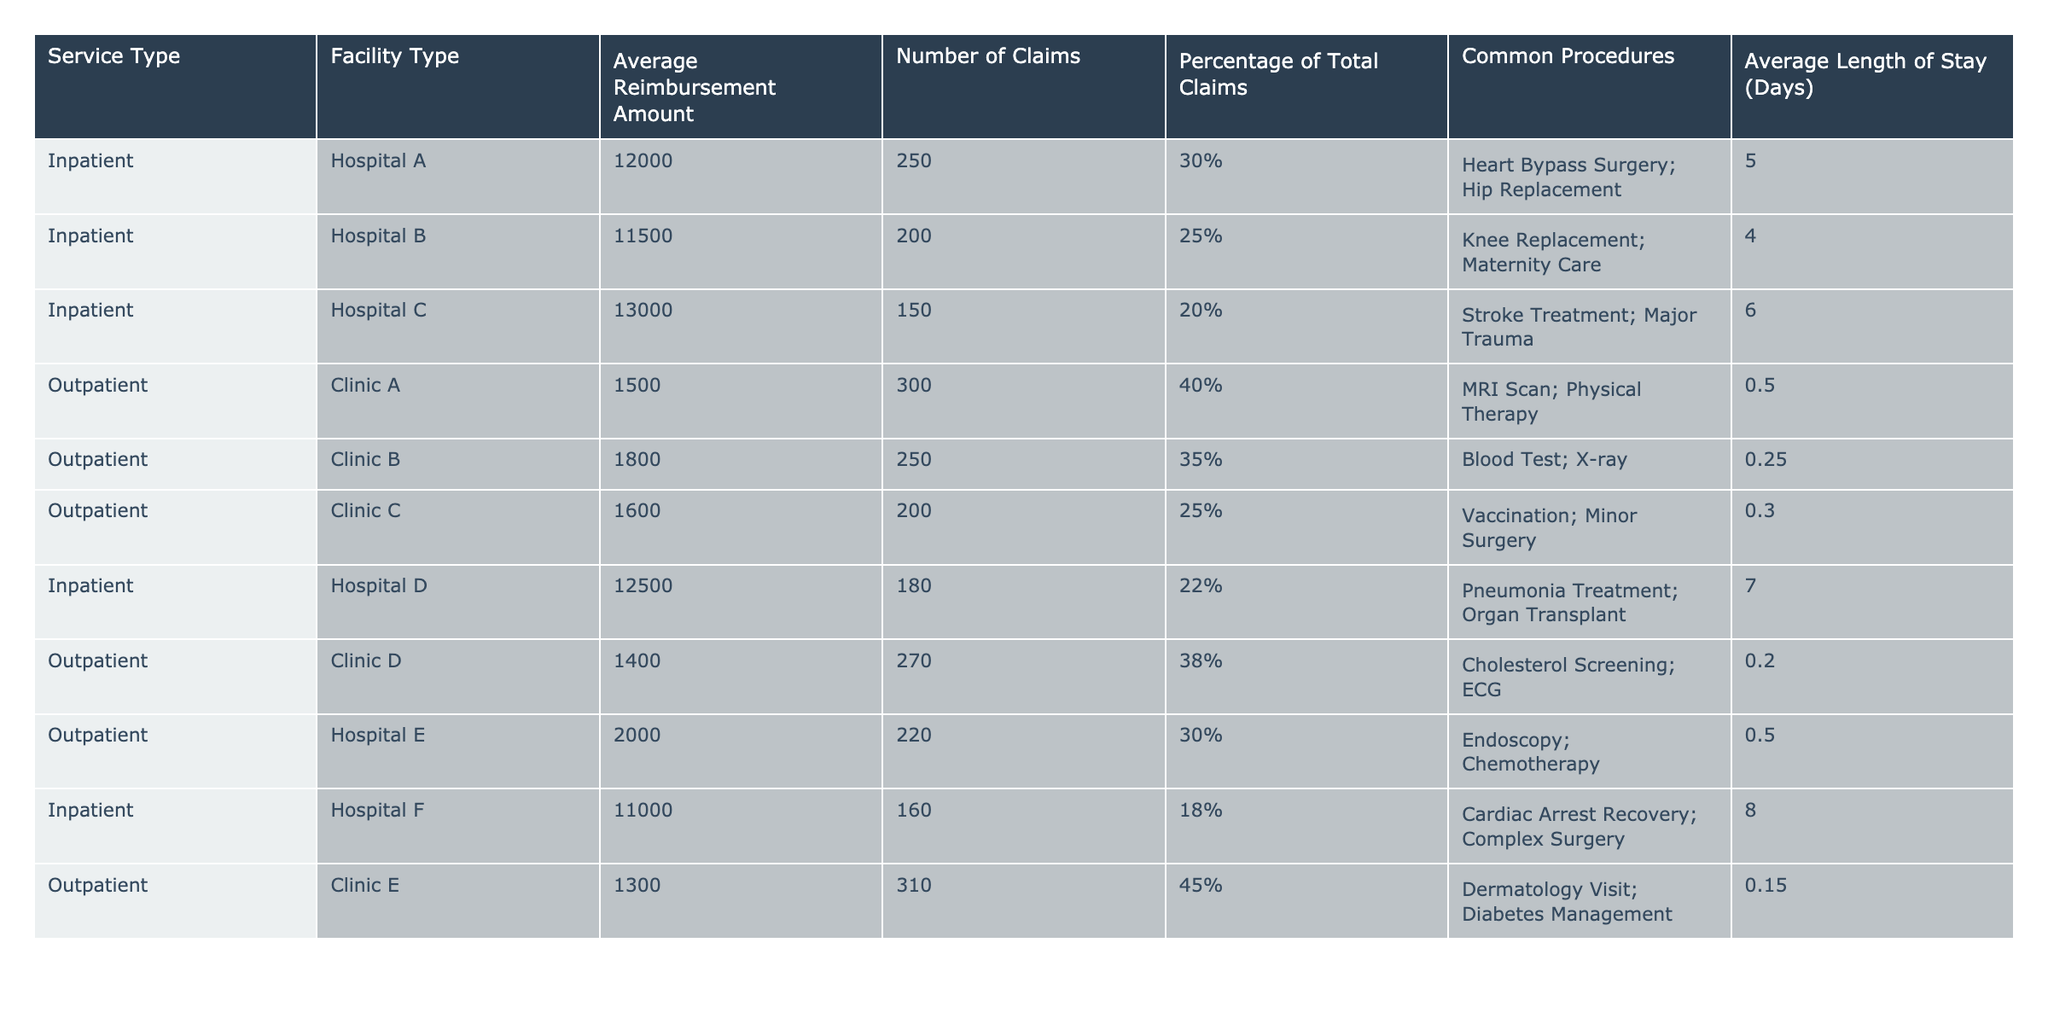What is the highest average reimbursement amount for inpatient services? The table lists the average reimbursement amounts for inpatient services in different hospitals. The highest value is 13000 associated with Hospital C.
Answer: 13000 What percentage of total claims does Clinic E account for? Clinic E's claims contribute to the total claims percentage based on its individual number of claims. With 310 claims out of a total of 1800 (250 + 200 + 150 + 180 + 310 = 1090), the percentage is (310 / 1090) * 100 ≈ 28.4%.
Answer: 28.4% How many days, on average, do inpatient services require? To find the average length of stay for inpatient services, we can sum the average lengths of stay for all inpatient services: 5 + 4 + 6 + 7 + 8 = 30 days, then divide by the number of inpatient services (6): 30 / 6 ≈ 5 days.
Answer: 5 days Is the average reimbursement amount for outpatient services higher than for inpatient services? The average reimbursement for outpatient services can be computed as (1500 + 1800 + 1600 + 1400 + 2000 + 1300) / 6 = 1550. The average inpatient reimbursement is calculated as (12000 + 11500 + 13000 + 12500 + 11000) / 5 = 12000. Since 1550 is less than 12000, the statement is false.
Answer: No What is the total reimbursement amount for all outpatient services combined? The total reimbursement amount for outpatient services can be found by summing the average reimbursement amounts multiplied by the number of claims for each outpatient clinic: (1500*300) + (1800*250) + (1600*200) + (1400*270) + (2000*220) + (1300*310) = 1245000.
Answer: 1245000 Which hospital has the second highest number of claims for inpatient services? By examining the number of claims for inpatient services in the hospitals, the order is Hospital A (250), Hospital B (200), Hospital D (180), Hospital C (150), and Hospital F (160). The second highest value is Hospital B with 200 claims.
Answer: Hospital B What is the average length of stay for patients undergoing surgery at Hospital A? Hospital A's common procedures include heart bypass surgery and hip replacement. The average length of stay is specifically listed as 5 days in the table.
Answer: 5 days Is there an outpatient clinic that has a lower average reimbursement amount than Hospital F? Hospital F has an average reimbursement of 11000. Evaluating the outpatient clinics: Clinic A (1500), Clinic B (1800), Clinic C (1600), Clinic D (1400), Clinic E (1300), and Hospital E (2000) all have lower amounts than 11000. The statement is true.
Answer: Yes What is the average reimbursement amount for the top three inpatient services by claims? The top three inpatient services by claims are Hospital A (250), Hospital B (200), and Hospital D (180). The average reimbursement for these is (12000 + 11500 + 12500) / 3 = 12000.
Answer: 12000 Which type of service has a greater percentage of total claims: inpatient or outpatient? To evaluate percentages of total claims: Total inpatient claims = 250 + 200 + 150 + 180 + 160 = 940 and total outpatient claims = 300 + 250 + 200 + 270 + 220 + 310 = 1550. Calculating the percentages: inpatient (940 / (940 + 1550)) * 100 ≈ 37.8%, outpatient (1550 / (940 + 1550)) * 100 ≈ 62.2%. Outpatient service has a higher percentage.
Answer: Outpatient 